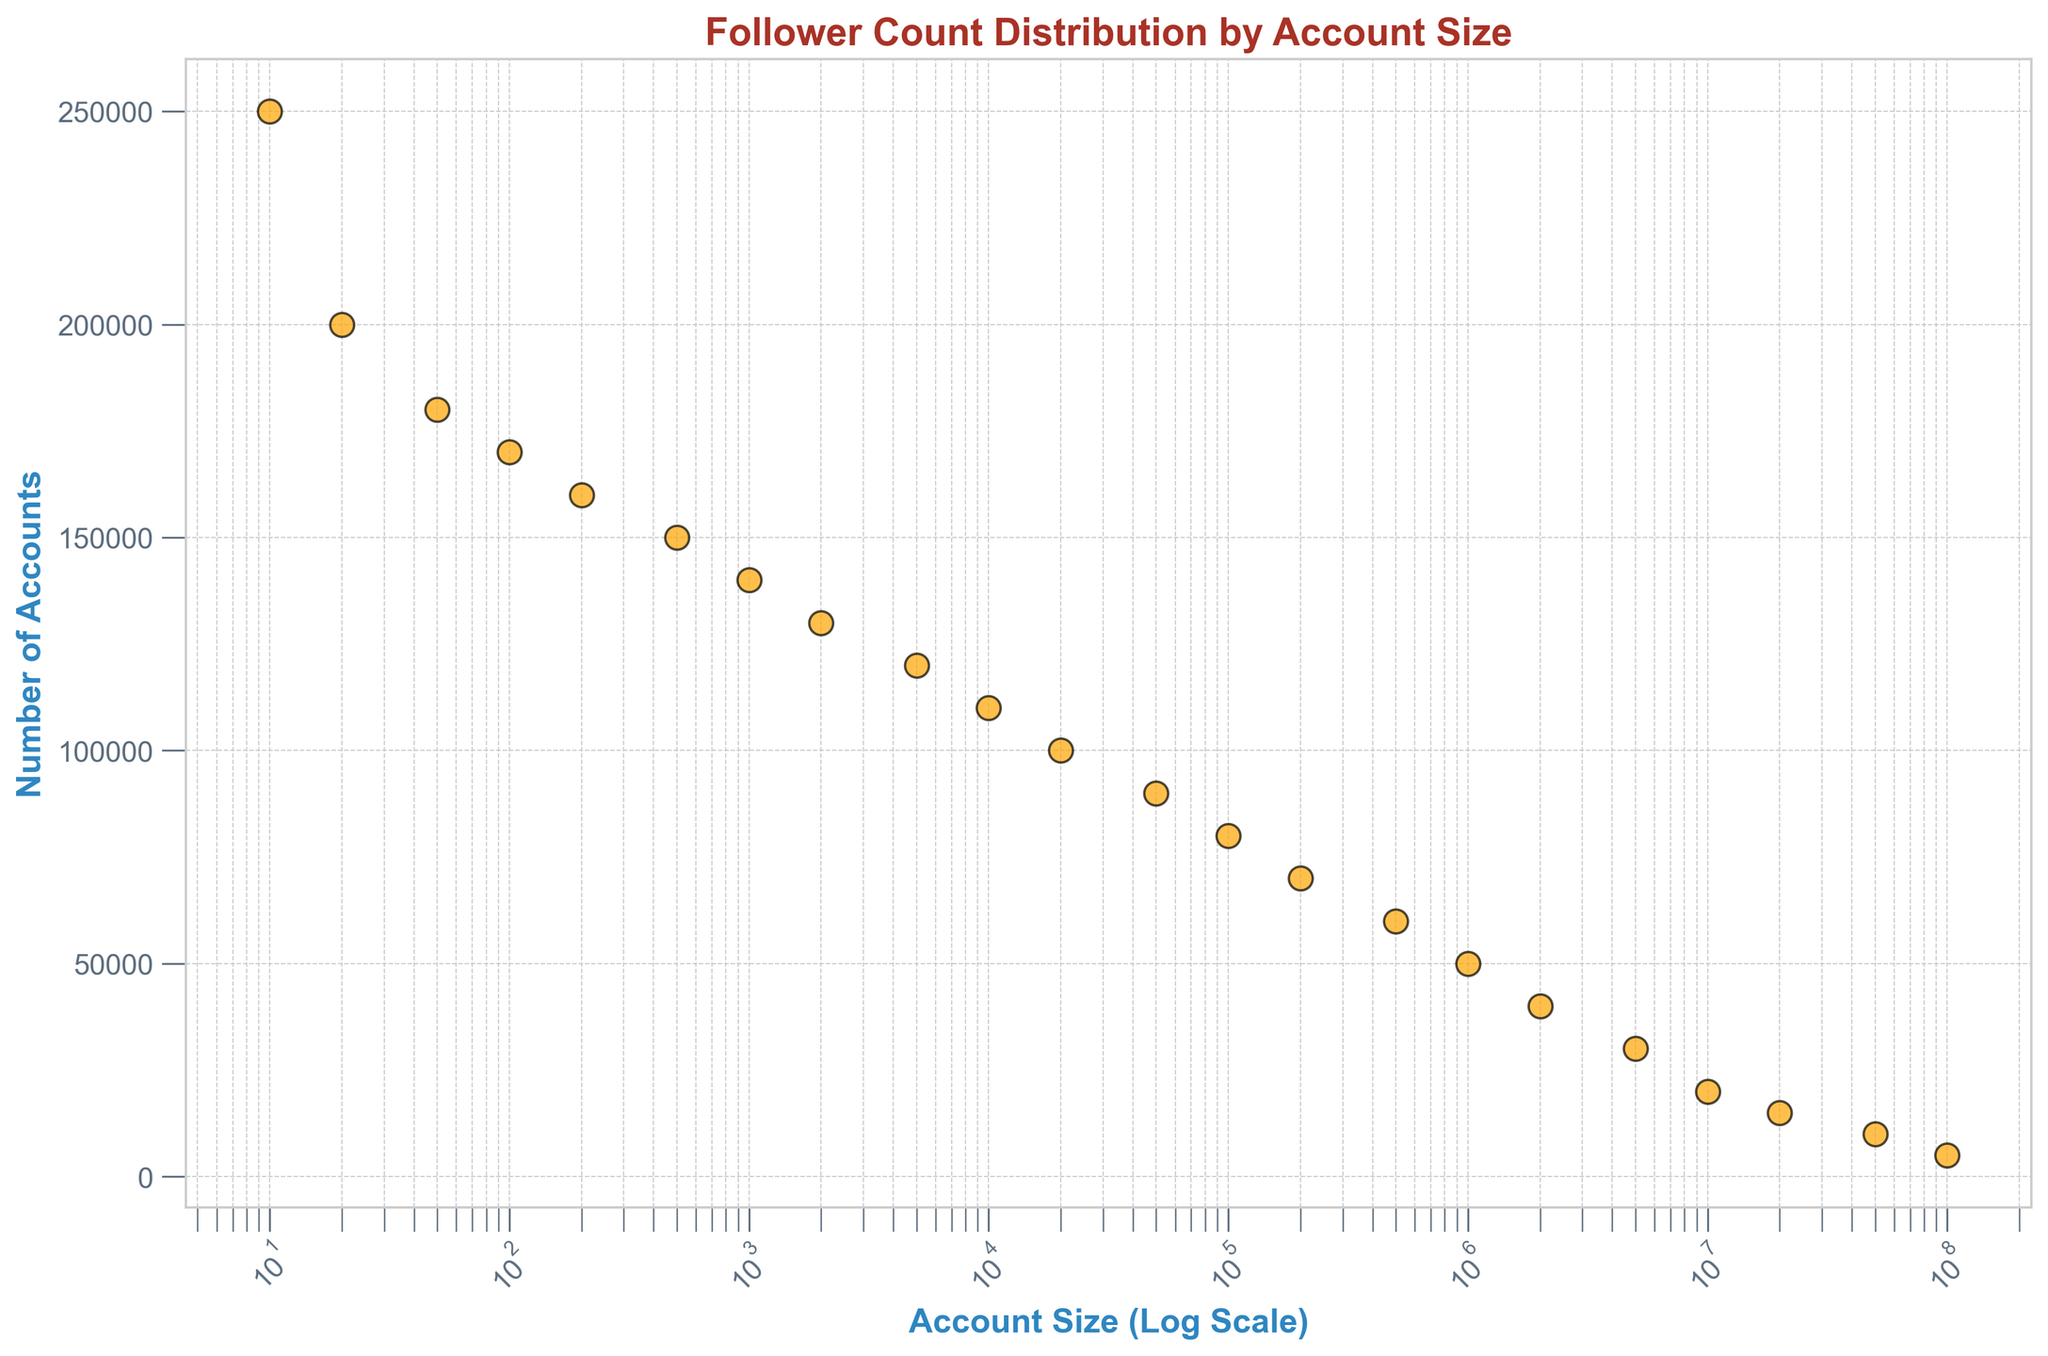Is the number of accounts with 1000 followers greater than the number of accounts with 500 followers? First, identify the number of accounts with 1000 followers, which is 140,000. Next, identify the number of accounts with 500 followers, which is 150,000. Compare the two values: 140,000 is not greater than 150,000.
Answer: No How does the number of accounts with 10,000 followers compare to those with 1,000,000 followers? First, find the number of accounts with 10,000 followers, which is 110,000. Then find the number of accounts with 1,000,000 followers, which is 50,000. Compare the two values: 110,000 is greater than 50,000.
Answer: 10,000 followers > 1,000,000 followers Among accounts with 50,000 followers and 100,000 followers, which has fewer accounts? Identify the number of accounts with 50,000 followers, which is 90,000. Then, identify the number of accounts with 100,000 followers, which is 80,000. Compare the two values: 80,000 is fewer than 90,000.
Answer: 100,000 followers By how much does the number of accounts with 200,000 followers exceed the number of accounts with 1,000,000 followers? Identify the number of accounts with 200,000 followers, which is 70,000. Then, find the number of accounts with 1,000,000 followers, which is 50,000. Subtract the latter from the former: 70,000 - 50,000 = 20,000.
Answer: 20,000 What is the trend in the number of accounts as the account size increases? Observe the scatter plot points on the log-scale x-axis. As the account size increases from 10 to 100,000,000 followers, the number of accounts tends to decline gradually. This indicates a negative trend.
Answer: Decreasing If we combine accounts with 500,000 and 1,000,000 followers, what is their total number? Identify the number of accounts with 500,000 followers, which is 60,000, and the number of accounts with 1,000,000 followers, which is 50,000. Sum up these values: 60,000 + 50,000 = 110,000.
Answer: 110,000 Compare the number of accounts with 20,000 followers to those with 100,000,000 followers. Identify the number of accounts with 20,000 followers, which is 100,000, and those with 100,000,000 followers, which is 5,000. Compare the two values: 100,000 is significantly greater than 5,000.
Answer: 20,000 followers > 100,000,000 followers Given accounts with 100 followers and 1000 followers, which one is higher in number and by how much? First, find the number of accounts with 100 followers, which is 170,000, and those with 1000 followers, which is 140,000. Subtract the smaller number from the larger number: 170,000 - 140,000 = 30,000.
Answer: 100 followers by 30,000 What is the most common follower range among the data provided? Observe the y-axis values in the scatter plot for different follower ranges. The highest point corresponds to accounts with 10 followers, which is 250,000.
Answer: 10 followers 